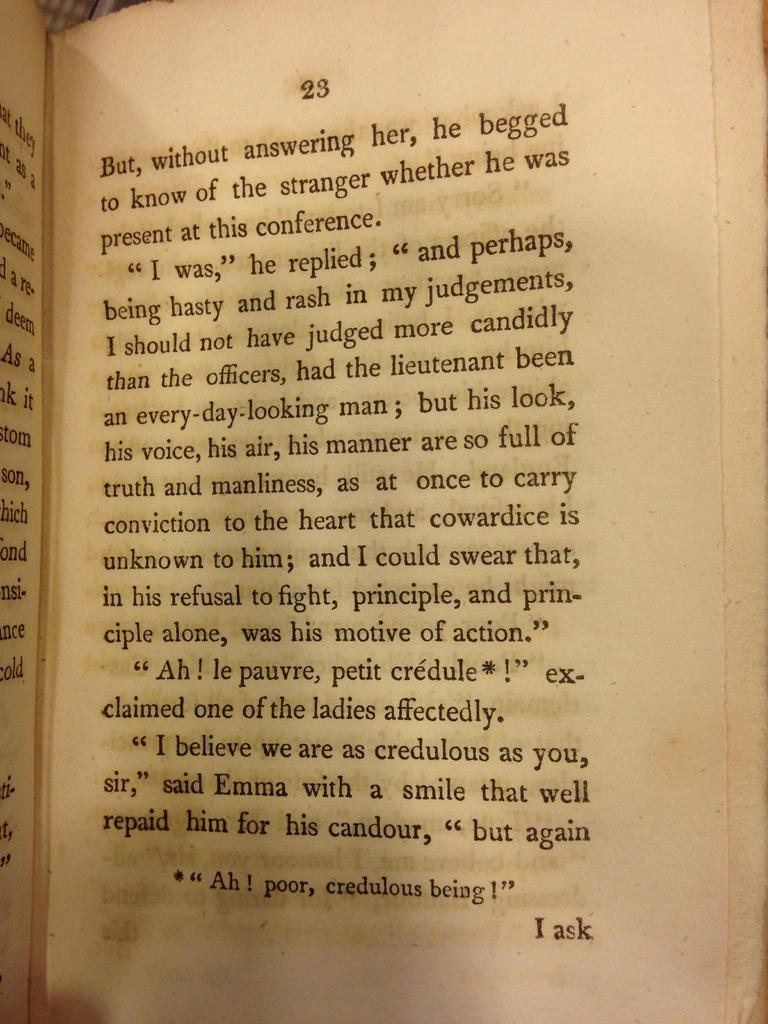<image>
Give a short and clear explanation of the subsequent image. A book open to page 23 that says I ask on the bottom 